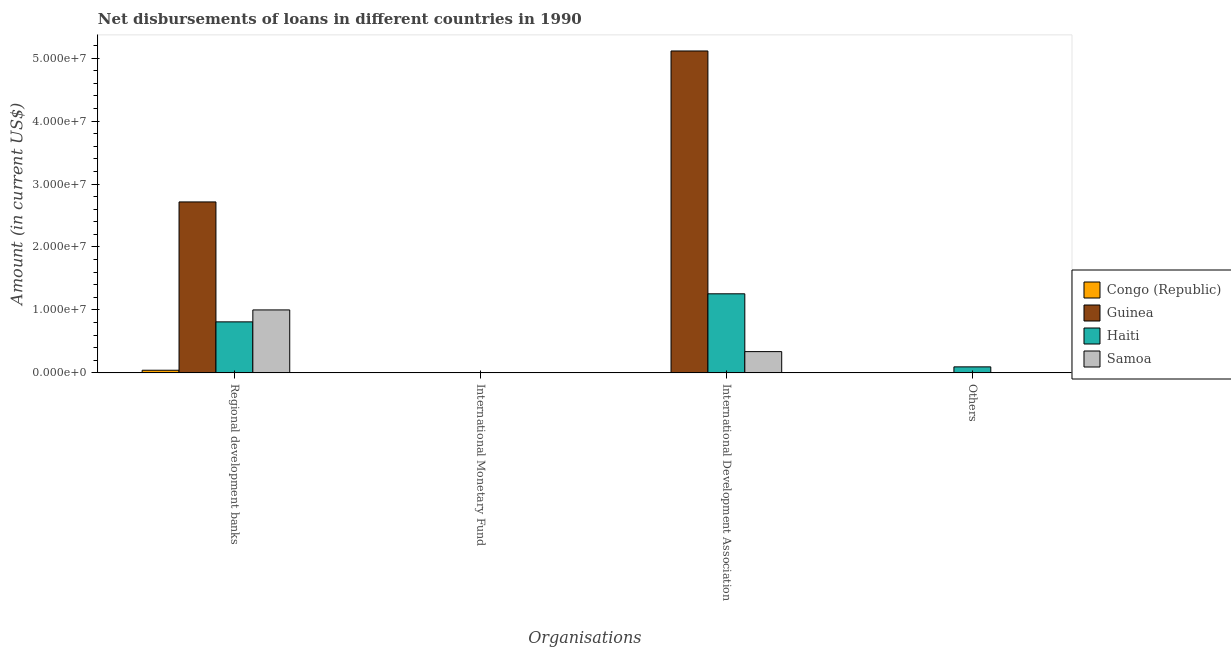What is the label of the 4th group of bars from the left?
Your response must be concise. Others. What is the amount of loan disimbursed by other organisations in Haiti?
Make the answer very short. 9.54e+05. Across all countries, what is the maximum amount of loan disimbursed by international development association?
Offer a very short reply. 5.11e+07. Across all countries, what is the minimum amount of loan disimbursed by international monetary fund?
Provide a succinct answer. 0. In which country was the amount of loan disimbursed by international development association maximum?
Offer a terse response. Guinea. What is the total amount of loan disimbursed by other organisations in the graph?
Make the answer very short. 9.54e+05. What is the difference between the amount of loan disimbursed by international development association in Guinea and that in Haiti?
Your answer should be compact. 3.86e+07. What is the difference between the amount of loan disimbursed by international development association in Samoa and the amount of loan disimbursed by international monetary fund in Congo (Republic)?
Keep it short and to the point. 3.38e+06. What is the difference between the amount of loan disimbursed by international development association and amount of loan disimbursed by regional development banks in Guinea?
Ensure brevity in your answer.  2.40e+07. What is the ratio of the amount of loan disimbursed by regional development banks in Congo (Republic) to that in Guinea?
Offer a terse response. 0.02. What is the difference between the highest and the second highest amount of loan disimbursed by regional development banks?
Your answer should be compact. 1.72e+07. What is the difference between the highest and the lowest amount of loan disimbursed by other organisations?
Offer a very short reply. 9.54e+05. Does the graph contain any zero values?
Keep it short and to the point. Yes. What is the title of the graph?
Give a very brief answer. Net disbursements of loans in different countries in 1990. Does "Angola" appear as one of the legend labels in the graph?
Your response must be concise. No. What is the label or title of the X-axis?
Give a very brief answer. Organisations. What is the Amount (in current US$) in Congo (Republic) in Regional development banks?
Your answer should be very brief. 4.16e+05. What is the Amount (in current US$) in Guinea in Regional development banks?
Give a very brief answer. 2.72e+07. What is the Amount (in current US$) of Haiti in Regional development banks?
Provide a succinct answer. 8.10e+06. What is the Amount (in current US$) in Samoa in Regional development banks?
Your answer should be compact. 1.00e+07. What is the Amount (in current US$) in Haiti in International Monetary Fund?
Ensure brevity in your answer.  0. What is the Amount (in current US$) in Samoa in International Monetary Fund?
Your answer should be very brief. 0. What is the Amount (in current US$) in Congo (Republic) in International Development Association?
Provide a short and direct response. 0. What is the Amount (in current US$) of Guinea in International Development Association?
Provide a short and direct response. 5.11e+07. What is the Amount (in current US$) in Haiti in International Development Association?
Offer a terse response. 1.26e+07. What is the Amount (in current US$) in Samoa in International Development Association?
Your response must be concise. 3.38e+06. What is the Amount (in current US$) in Guinea in Others?
Provide a succinct answer. 0. What is the Amount (in current US$) in Haiti in Others?
Provide a succinct answer. 9.54e+05. What is the Amount (in current US$) in Samoa in Others?
Ensure brevity in your answer.  0. Across all Organisations, what is the maximum Amount (in current US$) in Congo (Republic)?
Your answer should be very brief. 4.16e+05. Across all Organisations, what is the maximum Amount (in current US$) of Guinea?
Offer a terse response. 5.11e+07. Across all Organisations, what is the maximum Amount (in current US$) of Haiti?
Provide a short and direct response. 1.26e+07. Across all Organisations, what is the maximum Amount (in current US$) of Samoa?
Provide a short and direct response. 1.00e+07. Across all Organisations, what is the minimum Amount (in current US$) in Congo (Republic)?
Keep it short and to the point. 0. Across all Organisations, what is the minimum Amount (in current US$) of Samoa?
Your response must be concise. 0. What is the total Amount (in current US$) in Congo (Republic) in the graph?
Provide a succinct answer. 4.16e+05. What is the total Amount (in current US$) in Guinea in the graph?
Keep it short and to the point. 7.83e+07. What is the total Amount (in current US$) in Haiti in the graph?
Your answer should be compact. 2.16e+07. What is the total Amount (in current US$) of Samoa in the graph?
Give a very brief answer. 1.34e+07. What is the difference between the Amount (in current US$) of Guinea in Regional development banks and that in International Development Association?
Your answer should be compact. -2.40e+07. What is the difference between the Amount (in current US$) in Haiti in Regional development banks and that in International Development Association?
Offer a terse response. -4.46e+06. What is the difference between the Amount (in current US$) in Samoa in Regional development banks and that in International Development Association?
Your answer should be compact. 6.62e+06. What is the difference between the Amount (in current US$) of Haiti in Regional development banks and that in Others?
Provide a succinct answer. 7.15e+06. What is the difference between the Amount (in current US$) in Haiti in International Development Association and that in Others?
Provide a succinct answer. 1.16e+07. What is the difference between the Amount (in current US$) of Congo (Republic) in Regional development banks and the Amount (in current US$) of Guinea in International Development Association?
Ensure brevity in your answer.  -5.07e+07. What is the difference between the Amount (in current US$) in Congo (Republic) in Regional development banks and the Amount (in current US$) in Haiti in International Development Association?
Provide a short and direct response. -1.21e+07. What is the difference between the Amount (in current US$) of Congo (Republic) in Regional development banks and the Amount (in current US$) of Samoa in International Development Association?
Make the answer very short. -2.96e+06. What is the difference between the Amount (in current US$) of Guinea in Regional development banks and the Amount (in current US$) of Haiti in International Development Association?
Keep it short and to the point. 1.46e+07. What is the difference between the Amount (in current US$) of Guinea in Regional development banks and the Amount (in current US$) of Samoa in International Development Association?
Offer a very short reply. 2.38e+07. What is the difference between the Amount (in current US$) in Haiti in Regional development banks and the Amount (in current US$) in Samoa in International Development Association?
Provide a succinct answer. 4.73e+06. What is the difference between the Amount (in current US$) of Congo (Republic) in Regional development banks and the Amount (in current US$) of Haiti in Others?
Provide a succinct answer. -5.38e+05. What is the difference between the Amount (in current US$) of Guinea in Regional development banks and the Amount (in current US$) of Haiti in Others?
Provide a succinct answer. 2.62e+07. What is the difference between the Amount (in current US$) of Guinea in International Development Association and the Amount (in current US$) of Haiti in Others?
Give a very brief answer. 5.02e+07. What is the average Amount (in current US$) of Congo (Republic) per Organisations?
Offer a very short reply. 1.04e+05. What is the average Amount (in current US$) of Guinea per Organisations?
Provide a succinct answer. 1.96e+07. What is the average Amount (in current US$) of Haiti per Organisations?
Offer a terse response. 5.40e+06. What is the average Amount (in current US$) of Samoa per Organisations?
Offer a very short reply. 3.34e+06. What is the difference between the Amount (in current US$) of Congo (Republic) and Amount (in current US$) of Guinea in Regional development banks?
Keep it short and to the point. -2.67e+07. What is the difference between the Amount (in current US$) of Congo (Republic) and Amount (in current US$) of Haiti in Regional development banks?
Your answer should be very brief. -7.69e+06. What is the difference between the Amount (in current US$) of Congo (Republic) and Amount (in current US$) of Samoa in Regional development banks?
Offer a terse response. -9.58e+06. What is the difference between the Amount (in current US$) of Guinea and Amount (in current US$) of Haiti in Regional development banks?
Make the answer very short. 1.91e+07. What is the difference between the Amount (in current US$) of Guinea and Amount (in current US$) of Samoa in Regional development banks?
Offer a terse response. 1.72e+07. What is the difference between the Amount (in current US$) of Haiti and Amount (in current US$) of Samoa in Regional development banks?
Keep it short and to the point. -1.90e+06. What is the difference between the Amount (in current US$) in Guinea and Amount (in current US$) in Haiti in International Development Association?
Ensure brevity in your answer.  3.86e+07. What is the difference between the Amount (in current US$) in Guinea and Amount (in current US$) in Samoa in International Development Association?
Your response must be concise. 4.78e+07. What is the difference between the Amount (in current US$) of Haiti and Amount (in current US$) of Samoa in International Development Association?
Make the answer very short. 9.18e+06. What is the ratio of the Amount (in current US$) of Guinea in Regional development banks to that in International Development Association?
Make the answer very short. 0.53. What is the ratio of the Amount (in current US$) of Haiti in Regional development banks to that in International Development Association?
Ensure brevity in your answer.  0.65. What is the ratio of the Amount (in current US$) in Samoa in Regional development banks to that in International Development Association?
Your answer should be compact. 2.96. What is the ratio of the Amount (in current US$) of Haiti in Regional development banks to that in Others?
Your response must be concise. 8.49. What is the ratio of the Amount (in current US$) in Haiti in International Development Association to that in Others?
Your answer should be compact. 13.17. What is the difference between the highest and the second highest Amount (in current US$) in Haiti?
Ensure brevity in your answer.  4.46e+06. What is the difference between the highest and the lowest Amount (in current US$) in Congo (Republic)?
Offer a very short reply. 4.16e+05. What is the difference between the highest and the lowest Amount (in current US$) of Guinea?
Give a very brief answer. 5.11e+07. What is the difference between the highest and the lowest Amount (in current US$) in Haiti?
Ensure brevity in your answer.  1.26e+07. What is the difference between the highest and the lowest Amount (in current US$) of Samoa?
Your answer should be very brief. 1.00e+07. 